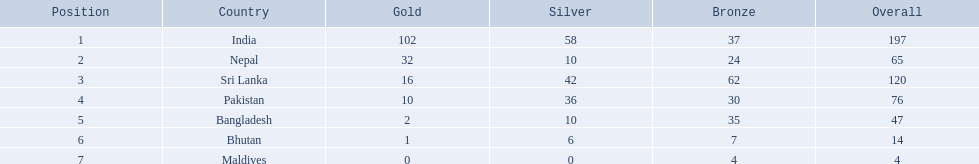Which countries won medals? India, Nepal, Sri Lanka, Pakistan, Bangladesh, Bhutan, Maldives. Which won the most? India. Which won the fewest? Maldives. What are all the countries listed in the table? India, Nepal, Sri Lanka, Pakistan, Bangladesh, Bhutan, Maldives. Can you give me this table as a dict? {'header': ['Position', 'Country', 'Gold', 'Silver', 'Bronze', 'Overall'], 'rows': [['1', 'India', '102', '58', '37', '197'], ['2', 'Nepal', '32', '10', '24', '65'], ['3', 'Sri Lanka', '16', '42', '62', '120'], ['4', 'Pakistan', '10', '36', '30', '76'], ['5', 'Bangladesh', '2', '10', '35', '47'], ['6', 'Bhutan', '1', '6', '7', '14'], ['7', 'Maldives', '0', '0', '4', '4']]} Which of these is not india? Nepal, Sri Lanka, Pakistan, Bangladesh, Bhutan, Maldives. Of these, which is first? Nepal. 